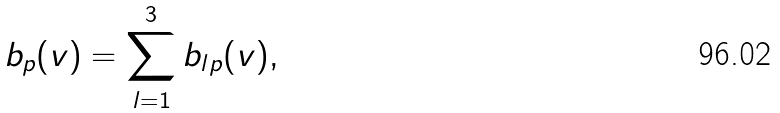<formula> <loc_0><loc_0><loc_500><loc_500>b _ { p } ( v ) = \sum _ { l = 1 } ^ { 3 } b _ { l p } ( v ) ,</formula> 